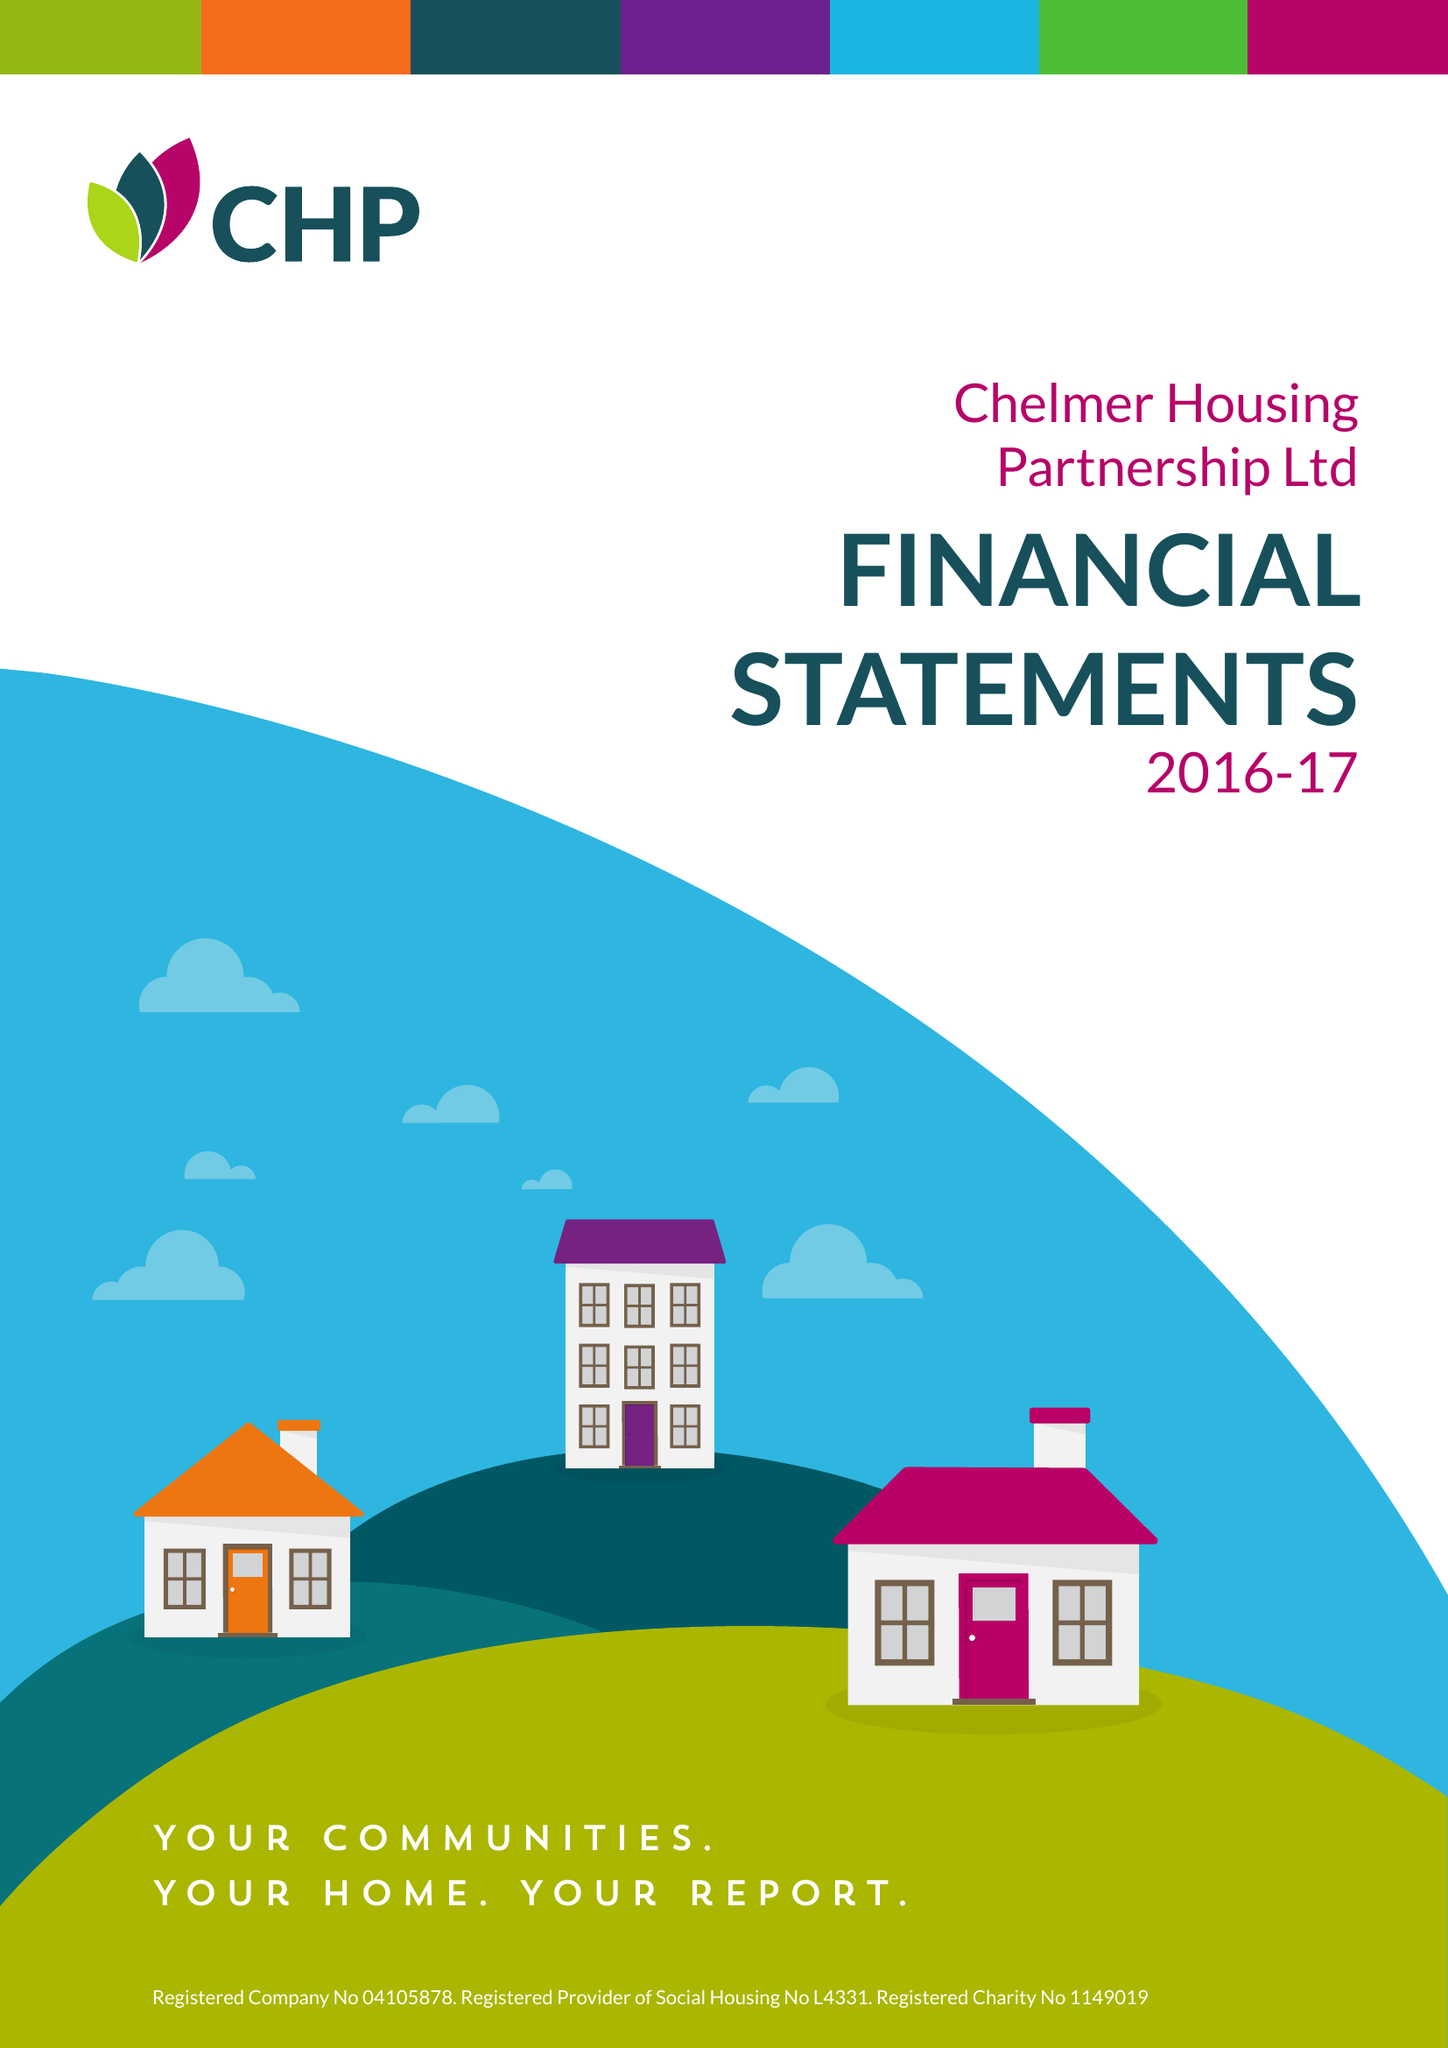What is the value for the income_annually_in_british_pounds?
Answer the question using a single word or phrase. 62627000.00 